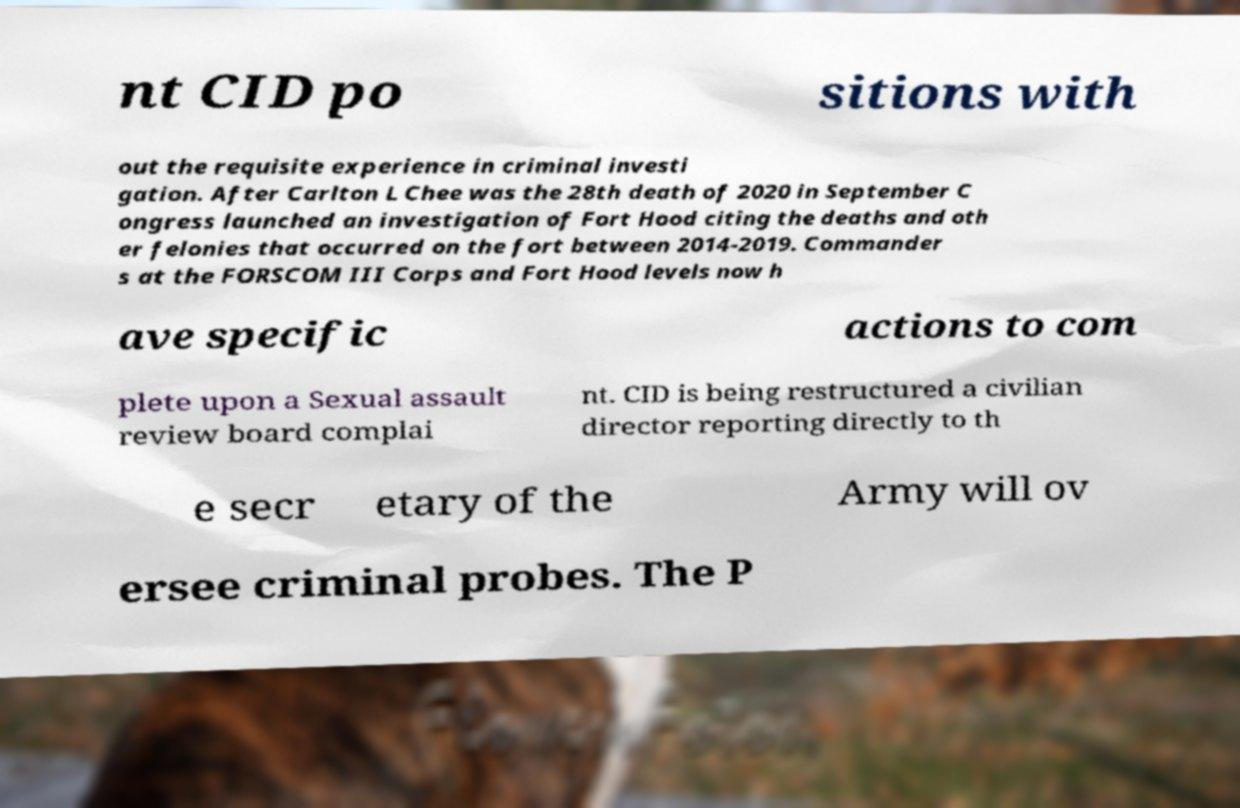What messages or text are displayed in this image? I need them in a readable, typed format. nt CID po sitions with out the requisite experience in criminal investi gation. After Carlton L Chee was the 28th death of 2020 in September C ongress launched an investigation of Fort Hood citing the deaths and oth er felonies that occurred on the fort between 2014-2019. Commander s at the FORSCOM III Corps and Fort Hood levels now h ave specific actions to com plete upon a Sexual assault review board complai nt. CID is being restructured a civilian director reporting directly to th e secr etary of the Army will ov ersee criminal probes. The P 